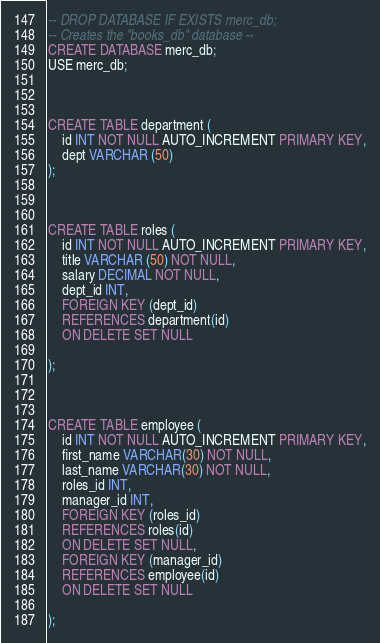<code> <loc_0><loc_0><loc_500><loc_500><_SQL_>
-- DROP DATABASE IF EXISTS merc_db;
-- Creates the "books_db" database --
CREATE DATABASE merc_db;
USE merc_db;



CREATE TABLE department (
    id INT NOT NULL AUTO_INCREMENT PRIMARY KEY,
    dept VARCHAR (50)
);



CREATE TABLE roles (
    id INT NOT NULL AUTO_INCREMENT PRIMARY KEY,
    title VARCHAR (50) NOT NULL,
    salary DECIMAL NOT NULL,
    dept_id INT,
    FOREIGN KEY (dept_id)
    REFERENCES department(id)
    ON DELETE SET NULL

);



CREATE TABLE employee (
    id INT NOT NULL AUTO_INCREMENT PRIMARY KEY,
    first_name VARCHAR(30) NOT NULL,
    last_name VARCHAR(30) NOT NULL,
    roles_id INT,
    manager_id INT,
    FOREIGN KEY (roles_id)
    REFERENCES roles(id)
    ON DELETE SET NULL,
    FOREIGN KEY (manager_id)
    REFERENCES employee(id)
    ON DELETE SET NULL
    
);</code> 